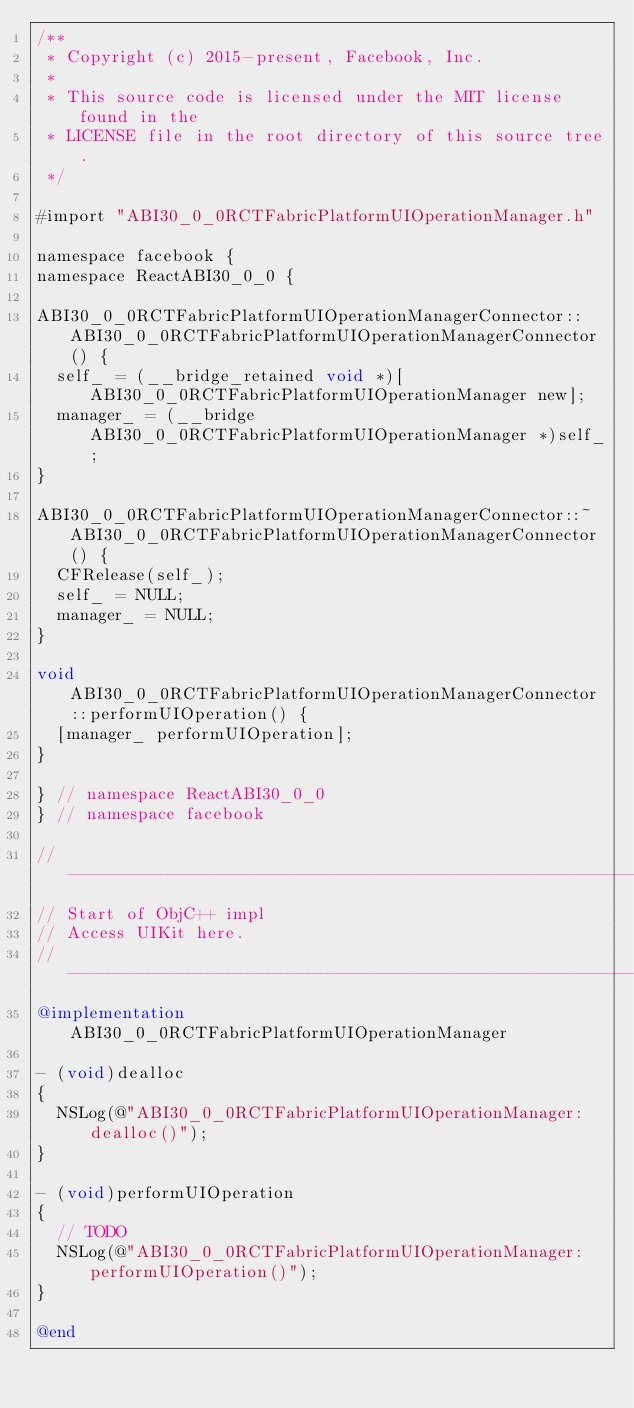Convert code to text. <code><loc_0><loc_0><loc_500><loc_500><_ObjectiveC_>/**
 * Copyright (c) 2015-present, Facebook, Inc.
 *
 * This source code is licensed under the MIT license found in the
 * LICENSE file in the root directory of this source tree.
 */

#import "ABI30_0_0RCTFabricPlatformUIOperationManager.h"

namespace facebook {
namespace ReactABI30_0_0 {

ABI30_0_0RCTFabricPlatformUIOperationManagerConnector::ABI30_0_0RCTFabricPlatformUIOperationManagerConnector() {
  self_ = (__bridge_retained void *)[ABI30_0_0RCTFabricPlatformUIOperationManager new];
  manager_ = (__bridge ABI30_0_0RCTFabricPlatformUIOperationManager *)self_;
}

ABI30_0_0RCTFabricPlatformUIOperationManagerConnector::~ABI30_0_0RCTFabricPlatformUIOperationManagerConnector() {
  CFRelease(self_);
  self_ = NULL;
  manager_ = NULL;
}

void ABI30_0_0RCTFabricPlatformUIOperationManagerConnector::performUIOperation() {
  [manager_ performUIOperation];
}

} // namespace ReactABI30_0_0
} // namespace facebook

// -----------------------------------------------------------------------------
// Start of ObjC++ impl
// Access UIKit here.
// -----------------------------------------------------------------------------
@implementation ABI30_0_0RCTFabricPlatformUIOperationManager

- (void)dealloc
{
  NSLog(@"ABI30_0_0RCTFabricPlatformUIOperationManager: dealloc()");
}

- (void)performUIOperation
{
  // TODO
  NSLog(@"ABI30_0_0RCTFabricPlatformUIOperationManager: performUIOperation()");
}

@end
</code> 